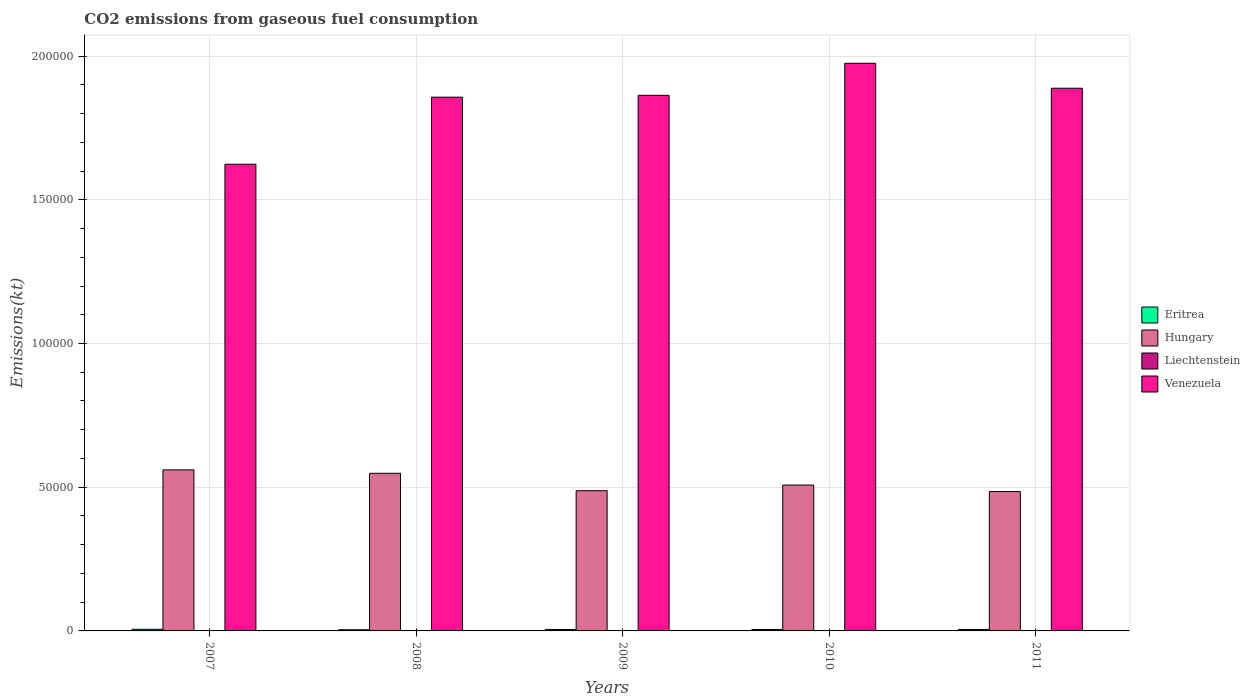How many different coloured bars are there?
Provide a succinct answer. 4. Are the number of bars per tick equal to the number of legend labels?
Ensure brevity in your answer.  Yes. What is the label of the 4th group of bars from the left?
Ensure brevity in your answer.  2010. In how many cases, is the number of bars for a given year not equal to the number of legend labels?
Your response must be concise. 0. What is the amount of CO2 emitted in Eritrea in 2009?
Your answer should be compact. 513.38. Across all years, what is the maximum amount of CO2 emitted in Venezuela?
Ensure brevity in your answer.  1.98e+05. Across all years, what is the minimum amount of CO2 emitted in Hungary?
Keep it short and to the point. 4.85e+04. What is the total amount of CO2 emitted in Liechtenstein in the graph?
Ensure brevity in your answer.  304.36. What is the difference between the amount of CO2 emitted in Eritrea in 2009 and that in 2011?
Offer a terse response. -7.33. What is the difference between the amount of CO2 emitted in Eritrea in 2011 and the amount of CO2 emitted in Hungary in 2010?
Your answer should be very brief. -5.02e+04. What is the average amount of CO2 emitted in Hungary per year?
Give a very brief answer. 5.18e+04. In the year 2011, what is the difference between the amount of CO2 emitted in Eritrea and amount of CO2 emitted in Venezuela?
Your answer should be compact. -1.88e+05. What is the ratio of the amount of CO2 emitted in Venezuela in 2008 to that in 2011?
Make the answer very short. 0.98. Is the amount of CO2 emitted in Hungary in 2007 less than that in 2010?
Offer a very short reply. No. What is the difference between the highest and the second highest amount of CO2 emitted in Venezuela?
Your answer should be very brief. 8694.46. What is the difference between the highest and the lowest amount of CO2 emitted in Venezuela?
Your answer should be compact. 3.51e+04. In how many years, is the amount of CO2 emitted in Liechtenstein greater than the average amount of CO2 emitted in Liechtenstein taken over all years?
Your answer should be very brief. 2. Is the sum of the amount of CO2 emitted in Hungary in 2007 and 2009 greater than the maximum amount of CO2 emitted in Venezuela across all years?
Ensure brevity in your answer.  No. Is it the case that in every year, the sum of the amount of CO2 emitted in Venezuela and amount of CO2 emitted in Liechtenstein is greater than the sum of amount of CO2 emitted in Hungary and amount of CO2 emitted in Eritrea?
Provide a short and direct response. No. What does the 2nd bar from the left in 2008 represents?
Provide a short and direct response. Hungary. What does the 1st bar from the right in 2009 represents?
Provide a short and direct response. Venezuela. How many years are there in the graph?
Offer a very short reply. 5. What is the difference between two consecutive major ticks on the Y-axis?
Offer a terse response. 5.00e+04. Does the graph contain grids?
Ensure brevity in your answer.  Yes. Where does the legend appear in the graph?
Provide a short and direct response. Center right. What is the title of the graph?
Keep it short and to the point. CO2 emissions from gaseous fuel consumption. What is the label or title of the X-axis?
Offer a very short reply. Years. What is the label or title of the Y-axis?
Offer a very short reply. Emissions(kt). What is the Emissions(kt) in Eritrea in 2007?
Keep it short and to the point. 579.39. What is the Emissions(kt) in Hungary in 2007?
Provide a short and direct response. 5.60e+04. What is the Emissions(kt) in Liechtenstein in 2007?
Provide a short and direct response. 69.67. What is the Emissions(kt) in Venezuela in 2007?
Your answer should be very brief. 1.62e+05. What is the Emissions(kt) in Eritrea in 2008?
Offer a terse response. 414.37. What is the Emissions(kt) in Hungary in 2008?
Offer a very short reply. 5.48e+04. What is the Emissions(kt) of Liechtenstein in 2008?
Make the answer very short. 69.67. What is the Emissions(kt) in Venezuela in 2008?
Ensure brevity in your answer.  1.86e+05. What is the Emissions(kt) of Eritrea in 2009?
Provide a short and direct response. 513.38. What is the Emissions(kt) of Hungary in 2009?
Provide a succinct answer. 4.88e+04. What is the Emissions(kt) in Liechtenstein in 2009?
Offer a terse response. 55.01. What is the Emissions(kt) of Venezuela in 2009?
Keep it short and to the point. 1.86e+05. What is the Emissions(kt) of Eritrea in 2010?
Provide a short and direct response. 513.38. What is the Emissions(kt) of Hungary in 2010?
Give a very brief answer. 5.07e+04. What is the Emissions(kt) of Liechtenstein in 2010?
Offer a terse response. 58.67. What is the Emissions(kt) of Venezuela in 2010?
Make the answer very short. 1.98e+05. What is the Emissions(kt) in Eritrea in 2011?
Keep it short and to the point. 520.71. What is the Emissions(kt) in Hungary in 2011?
Provide a succinct answer. 4.85e+04. What is the Emissions(kt) in Liechtenstein in 2011?
Keep it short and to the point. 51.34. What is the Emissions(kt) of Venezuela in 2011?
Provide a short and direct response. 1.89e+05. Across all years, what is the maximum Emissions(kt) in Eritrea?
Your answer should be compact. 579.39. Across all years, what is the maximum Emissions(kt) in Hungary?
Your response must be concise. 5.60e+04. Across all years, what is the maximum Emissions(kt) in Liechtenstein?
Make the answer very short. 69.67. Across all years, what is the maximum Emissions(kt) in Venezuela?
Offer a terse response. 1.98e+05. Across all years, what is the minimum Emissions(kt) of Eritrea?
Provide a succinct answer. 414.37. Across all years, what is the minimum Emissions(kt) of Hungary?
Provide a short and direct response. 4.85e+04. Across all years, what is the minimum Emissions(kt) in Liechtenstein?
Provide a succinct answer. 51.34. Across all years, what is the minimum Emissions(kt) of Venezuela?
Ensure brevity in your answer.  1.62e+05. What is the total Emissions(kt) of Eritrea in the graph?
Offer a very short reply. 2541.23. What is the total Emissions(kt) in Hungary in the graph?
Give a very brief answer. 2.59e+05. What is the total Emissions(kt) in Liechtenstein in the graph?
Your answer should be compact. 304.36. What is the total Emissions(kt) in Venezuela in the graph?
Offer a terse response. 9.21e+05. What is the difference between the Emissions(kt) in Eritrea in 2007 and that in 2008?
Give a very brief answer. 165.01. What is the difference between the Emissions(kt) in Hungary in 2007 and that in 2008?
Offer a very short reply. 1191.78. What is the difference between the Emissions(kt) in Liechtenstein in 2007 and that in 2008?
Provide a succinct answer. 0. What is the difference between the Emissions(kt) in Venezuela in 2007 and that in 2008?
Your answer should be very brief. -2.33e+04. What is the difference between the Emissions(kt) of Eritrea in 2007 and that in 2009?
Ensure brevity in your answer.  66.01. What is the difference between the Emissions(kt) in Hungary in 2007 and that in 2009?
Ensure brevity in your answer.  7253.33. What is the difference between the Emissions(kt) in Liechtenstein in 2007 and that in 2009?
Give a very brief answer. 14.67. What is the difference between the Emissions(kt) in Venezuela in 2007 and that in 2009?
Provide a short and direct response. -2.40e+04. What is the difference between the Emissions(kt) of Eritrea in 2007 and that in 2010?
Make the answer very short. 66.01. What is the difference between the Emissions(kt) in Hungary in 2007 and that in 2010?
Provide a short and direct response. 5287.81. What is the difference between the Emissions(kt) of Liechtenstein in 2007 and that in 2010?
Your answer should be very brief. 11. What is the difference between the Emissions(kt) in Venezuela in 2007 and that in 2010?
Provide a short and direct response. -3.51e+04. What is the difference between the Emissions(kt) in Eritrea in 2007 and that in 2011?
Your answer should be compact. 58.67. What is the difference between the Emissions(kt) in Hungary in 2007 and that in 2011?
Make the answer very short. 7543.02. What is the difference between the Emissions(kt) in Liechtenstein in 2007 and that in 2011?
Your answer should be very brief. 18.34. What is the difference between the Emissions(kt) of Venezuela in 2007 and that in 2011?
Offer a terse response. -2.64e+04. What is the difference between the Emissions(kt) of Eritrea in 2008 and that in 2009?
Offer a very short reply. -99.01. What is the difference between the Emissions(kt) in Hungary in 2008 and that in 2009?
Give a very brief answer. 6061.55. What is the difference between the Emissions(kt) in Liechtenstein in 2008 and that in 2009?
Ensure brevity in your answer.  14.67. What is the difference between the Emissions(kt) in Venezuela in 2008 and that in 2009?
Make the answer very short. -645.39. What is the difference between the Emissions(kt) of Eritrea in 2008 and that in 2010?
Provide a short and direct response. -99.01. What is the difference between the Emissions(kt) in Hungary in 2008 and that in 2010?
Offer a very short reply. 4096.04. What is the difference between the Emissions(kt) in Liechtenstein in 2008 and that in 2010?
Your response must be concise. 11. What is the difference between the Emissions(kt) of Venezuela in 2008 and that in 2010?
Provide a succinct answer. -1.18e+04. What is the difference between the Emissions(kt) in Eritrea in 2008 and that in 2011?
Offer a terse response. -106.34. What is the difference between the Emissions(kt) of Hungary in 2008 and that in 2011?
Your response must be concise. 6351.24. What is the difference between the Emissions(kt) of Liechtenstein in 2008 and that in 2011?
Offer a very short reply. 18.34. What is the difference between the Emissions(kt) of Venezuela in 2008 and that in 2011?
Provide a short and direct response. -3109.62. What is the difference between the Emissions(kt) in Hungary in 2009 and that in 2010?
Ensure brevity in your answer.  -1965.51. What is the difference between the Emissions(kt) of Liechtenstein in 2009 and that in 2010?
Offer a terse response. -3.67. What is the difference between the Emissions(kt) in Venezuela in 2009 and that in 2010?
Offer a terse response. -1.12e+04. What is the difference between the Emissions(kt) of Eritrea in 2009 and that in 2011?
Provide a succinct answer. -7.33. What is the difference between the Emissions(kt) in Hungary in 2009 and that in 2011?
Your response must be concise. 289.69. What is the difference between the Emissions(kt) in Liechtenstein in 2009 and that in 2011?
Provide a succinct answer. 3.67. What is the difference between the Emissions(kt) of Venezuela in 2009 and that in 2011?
Ensure brevity in your answer.  -2464.22. What is the difference between the Emissions(kt) of Eritrea in 2010 and that in 2011?
Offer a very short reply. -7.33. What is the difference between the Emissions(kt) in Hungary in 2010 and that in 2011?
Your answer should be compact. 2255.2. What is the difference between the Emissions(kt) in Liechtenstein in 2010 and that in 2011?
Your answer should be very brief. 7.33. What is the difference between the Emissions(kt) of Venezuela in 2010 and that in 2011?
Keep it short and to the point. 8694.46. What is the difference between the Emissions(kt) in Eritrea in 2007 and the Emissions(kt) in Hungary in 2008?
Provide a succinct answer. -5.43e+04. What is the difference between the Emissions(kt) of Eritrea in 2007 and the Emissions(kt) of Liechtenstein in 2008?
Provide a short and direct response. 509.71. What is the difference between the Emissions(kt) in Eritrea in 2007 and the Emissions(kt) in Venezuela in 2008?
Keep it short and to the point. -1.85e+05. What is the difference between the Emissions(kt) in Hungary in 2007 and the Emissions(kt) in Liechtenstein in 2008?
Ensure brevity in your answer.  5.60e+04. What is the difference between the Emissions(kt) in Hungary in 2007 and the Emissions(kt) in Venezuela in 2008?
Offer a very short reply. -1.30e+05. What is the difference between the Emissions(kt) of Liechtenstein in 2007 and the Emissions(kt) of Venezuela in 2008?
Give a very brief answer. -1.86e+05. What is the difference between the Emissions(kt) in Eritrea in 2007 and the Emissions(kt) in Hungary in 2009?
Give a very brief answer. -4.82e+04. What is the difference between the Emissions(kt) of Eritrea in 2007 and the Emissions(kt) of Liechtenstein in 2009?
Keep it short and to the point. 524.38. What is the difference between the Emissions(kt) of Eritrea in 2007 and the Emissions(kt) of Venezuela in 2009?
Provide a short and direct response. -1.86e+05. What is the difference between the Emissions(kt) in Hungary in 2007 and the Emissions(kt) in Liechtenstein in 2009?
Give a very brief answer. 5.60e+04. What is the difference between the Emissions(kt) of Hungary in 2007 and the Emissions(kt) of Venezuela in 2009?
Provide a succinct answer. -1.30e+05. What is the difference between the Emissions(kt) of Liechtenstein in 2007 and the Emissions(kt) of Venezuela in 2009?
Keep it short and to the point. -1.86e+05. What is the difference between the Emissions(kt) of Eritrea in 2007 and the Emissions(kt) of Hungary in 2010?
Your answer should be compact. -5.02e+04. What is the difference between the Emissions(kt) of Eritrea in 2007 and the Emissions(kt) of Liechtenstein in 2010?
Offer a terse response. 520.71. What is the difference between the Emissions(kt) of Eritrea in 2007 and the Emissions(kt) of Venezuela in 2010?
Give a very brief answer. -1.97e+05. What is the difference between the Emissions(kt) of Hungary in 2007 and the Emissions(kt) of Liechtenstein in 2010?
Offer a very short reply. 5.60e+04. What is the difference between the Emissions(kt) of Hungary in 2007 and the Emissions(kt) of Venezuela in 2010?
Ensure brevity in your answer.  -1.41e+05. What is the difference between the Emissions(kt) in Liechtenstein in 2007 and the Emissions(kt) in Venezuela in 2010?
Provide a short and direct response. -1.97e+05. What is the difference between the Emissions(kt) of Eritrea in 2007 and the Emissions(kt) of Hungary in 2011?
Keep it short and to the point. -4.79e+04. What is the difference between the Emissions(kt) of Eritrea in 2007 and the Emissions(kt) of Liechtenstein in 2011?
Keep it short and to the point. 528.05. What is the difference between the Emissions(kt) in Eritrea in 2007 and the Emissions(kt) in Venezuela in 2011?
Offer a terse response. -1.88e+05. What is the difference between the Emissions(kt) of Hungary in 2007 and the Emissions(kt) of Liechtenstein in 2011?
Make the answer very short. 5.60e+04. What is the difference between the Emissions(kt) of Hungary in 2007 and the Emissions(kt) of Venezuela in 2011?
Keep it short and to the point. -1.33e+05. What is the difference between the Emissions(kt) of Liechtenstein in 2007 and the Emissions(kt) of Venezuela in 2011?
Ensure brevity in your answer.  -1.89e+05. What is the difference between the Emissions(kt) in Eritrea in 2008 and the Emissions(kt) in Hungary in 2009?
Keep it short and to the point. -4.84e+04. What is the difference between the Emissions(kt) of Eritrea in 2008 and the Emissions(kt) of Liechtenstein in 2009?
Make the answer very short. 359.37. What is the difference between the Emissions(kt) of Eritrea in 2008 and the Emissions(kt) of Venezuela in 2009?
Your answer should be very brief. -1.86e+05. What is the difference between the Emissions(kt) in Hungary in 2008 and the Emissions(kt) in Liechtenstein in 2009?
Make the answer very short. 5.48e+04. What is the difference between the Emissions(kt) in Hungary in 2008 and the Emissions(kt) in Venezuela in 2009?
Keep it short and to the point. -1.32e+05. What is the difference between the Emissions(kt) of Liechtenstein in 2008 and the Emissions(kt) of Venezuela in 2009?
Ensure brevity in your answer.  -1.86e+05. What is the difference between the Emissions(kt) of Eritrea in 2008 and the Emissions(kt) of Hungary in 2010?
Ensure brevity in your answer.  -5.03e+04. What is the difference between the Emissions(kt) of Eritrea in 2008 and the Emissions(kt) of Liechtenstein in 2010?
Offer a very short reply. 355.7. What is the difference between the Emissions(kt) in Eritrea in 2008 and the Emissions(kt) in Venezuela in 2010?
Keep it short and to the point. -1.97e+05. What is the difference between the Emissions(kt) in Hungary in 2008 and the Emissions(kt) in Liechtenstein in 2010?
Offer a terse response. 5.48e+04. What is the difference between the Emissions(kt) in Hungary in 2008 and the Emissions(kt) in Venezuela in 2010?
Ensure brevity in your answer.  -1.43e+05. What is the difference between the Emissions(kt) of Liechtenstein in 2008 and the Emissions(kt) of Venezuela in 2010?
Provide a succinct answer. -1.97e+05. What is the difference between the Emissions(kt) in Eritrea in 2008 and the Emissions(kt) in Hungary in 2011?
Keep it short and to the point. -4.81e+04. What is the difference between the Emissions(kt) in Eritrea in 2008 and the Emissions(kt) in Liechtenstein in 2011?
Make the answer very short. 363.03. What is the difference between the Emissions(kt) in Eritrea in 2008 and the Emissions(kt) in Venezuela in 2011?
Your response must be concise. -1.88e+05. What is the difference between the Emissions(kt) in Hungary in 2008 and the Emissions(kt) in Liechtenstein in 2011?
Your response must be concise. 5.48e+04. What is the difference between the Emissions(kt) of Hungary in 2008 and the Emissions(kt) of Venezuela in 2011?
Make the answer very short. -1.34e+05. What is the difference between the Emissions(kt) in Liechtenstein in 2008 and the Emissions(kt) in Venezuela in 2011?
Provide a short and direct response. -1.89e+05. What is the difference between the Emissions(kt) in Eritrea in 2009 and the Emissions(kt) in Hungary in 2010?
Make the answer very short. -5.02e+04. What is the difference between the Emissions(kt) of Eritrea in 2009 and the Emissions(kt) of Liechtenstein in 2010?
Provide a short and direct response. 454.71. What is the difference between the Emissions(kt) in Eritrea in 2009 and the Emissions(kt) in Venezuela in 2010?
Ensure brevity in your answer.  -1.97e+05. What is the difference between the Emissions(kt) of Hungary in 2009 and the Emissions(kt) of Liechtenstein in 2010?
Keep it short and to the point. 4.87e+04. What is the difference between the Emissions(kt) in Hungary in 2009 and the Emissions(kt) in Venezuela in 2010?
Give a very brief answer. -1.49e+05. What is the difference between the Emissions(kt) of Liechtenstein in 2009 and the Emissions(kt) of Venezuela in 2010?
Make the answer very short. -1.97e+05. What is the difference between the Emissions(kt) of Eritrea in 2009 and the Emissions(kt) of Hungary in 2011?
Provide a succinct answer. -4.80e+04. What is the difference between the Emissions(kt) in Eritrea in 2009 and the Emissions(kt) in Liechtenstein in 2011?
Offer a very short reply. 462.04. What is the difference between the Emissions(kt) of Eritrea in 2009 and the Emissions(kt) of Venezuela in 2011?
Your response must be concise. -1.88e+05. What is the difference between the Emissions(kt) of Hungary in 2009 and the Emissions(kt) of Liechtenstein in 2011?
Your response must be concise. 4.87e+04. What is the difference between the Emissions(kt) in Hungary in 2009 and the Emissions(kt) in Venezuela in 2011?
Provide a succinct answer. -1.40e+05. What is the difference between the Emissions(kt) of Liechtenstein in 2009 and the Emissions(kt) of Venezuela in 2011?
Provide a succinct answer. -1.89e+05. What is the difference between the Emissions(kt) of Eritrea in 2010 and the Emissions(kt) of Hungary in 2011?
Provide a succinct answer. -4.80e+04. What is the difference between the Emissions(kt) of Eritrea in 2010 and the Emissions(kt) of Liechtenstein in 2011?
Your answer should be very brief. 462.04. What is the difference between the Emissions(kt) in Eritrea in 2010 and the Emissions(kt) in Venezuela in 2011?
Offer a terse response. -1.88e+05. What is the difference between the Emissions(kt) in Hungary in 2010 and the Emissions(kt) in Liechtenstein in 2011?
Give a very brief answer. 5.07e+04. What is the difference between the Emissions(kt) of Hungary in 2010 and the Emissions(kt) of Venezuela in 2011?
Your response must be concise. -1.38e+05. What is the difference between the Emissions(kt) of Liechtenstein in 2010 and the Emissions(kt) of Venezuela in 2011?
Offer a terse response. -1.89e+05. What is the average Emissions(kt) in Eritrea per year?
Your response must be concise. 508.25. What is the average Emissions(kt) of Hungary per year?
Provide a short and direct response. 5.18e+04. What is the average Emissions(kt) in Liechtenstein per year?
Make the answer very short. 60.87. What is the average Emissions(kt) in Venezuela per year?
Make the answer very short. 1.84e+05. In the year 2007, what is the difference between the Emissions(kt) of Eritrea and Emissions(kt) of Hungary?
Provide a succinct answer. -5.55e+04. In the year 2007, what is the difference between the Emissions(kt) of Eritrea and Emissions(kt) of Liechtenstein?
Keep it short and to the point. 509.71. In the year 2007, what is the difference between the Emissions(kt) of Eritrea and Emissions(kt) of Venezuela?
Provide a short and direct response. -1.62e+05. In the year 2007, what is the difference between the Emissions(kt) of Hungary and Emissions(kt) of Liechtenstein?
Give a very brief answer. 5.60e+04. In the year 2007, what is the difference between the Emissions(kt) of Hungary and Emissions(kt) of Venezuela?
Your answer should be compact. -1.06e+05. In the year 2007, what is the difference between the Emissions(kt) in Liechtenstein and Emissions(kt) in Venezuela?
Your response must be concise. -1.62e+05. In the year 2008, what is the difference between the Emissions(kt) in Eritrea and Emissions(kt) in Hungary?
Make the answer very short. -5.44e+04. In the year 2008, what is the difference between the Emissions(kt) in Eritrea and Emissions(kt) in Liechtenstein?
Your answer should be compact. 344.7. In the year 2008, what is the difference between the Emissions(kt) in Eritrea and Emissions(kt) in Venezuela?
Give a very brief answer. -1.85e+05. In the year 2008, what is the difference between the Emissions(kt) in Hungary and Emissions(kt) in Liechtenstein?
Ensure brevity in your answer.  5.48e+04. In the year 2008, what is the difference between the Emissions(kt) of Hungary and Emissions(kt) of Venezuela?
Provide a short and direct response. -1.31e+05. In the year 2008, what is the difference between the Emissions(kt) of Liechtenstein and Emissions(kt) of Venezuela?
Your answer should be compact. -1.86e+05. In the year 2009, what is the difference between the Emissions(kt) of Eritrea and Emissions(kt) of Hungary?
Your answer should be very brief. -4.83e+04. In the year 2009, what is the difference between the Emissions(kt) in Eritrea and Emissions(kt) in Liechtenstein?
Offer a very short reply. 458.38. In the year 2009, what is the difference between the Emissions(kt) in Eritrea and Emissions(kt) in Venezuela?
Offer a very short reply. -1.86e+05. In the year 2009, what is the difference between the Emissions(kt) in Hungary and Emissions(kt) in Liechtenstein?
Provide a succinct answer. 4.87e+04. In the year 2009, what is the difference between the Emissions(kt) in Hungary and Emissions(kt) in Venezuela?
Offer a very short reply. -1.38e+05. In the year 2009, what is the difference between the Emissions(kt) of Liechtenstein and Emissions(kt) of Venezuela?
Your response must be concise. -1.86e+05. In the year 2010, what is the difference between the Emissions(kt) in Eritrea and Emissions(kt) in Hungary?
Offer a very short reply. -5.02e+04. In the year 2010, what is the difference between the Emissions(kt) in Eritrea and Emissions(kt) in Liechtenstein?
Provide a short and direct response. 454.71. In the year 2010, what is the difference between the Emissions(kt) of Eritrea and Emissions(kt) of Venezuela?
Offer a very short reply. -1.97e+05. In the year 2010, what is the difference between the Emissions(kt) of Hungary and Emissions(kt) of Liechtenstein?
Give a very brief answer. 5.07e+04. In the year 2010, what is the difference between the Emissions(kt) of Hungary and Emissions(kt) of Venezuela?
Your answer should be compact. -1.47e+05. In the year 2010, what is the difference between the Emissions(kt) in Liechtenstein and Emissions(kt) in Venezuela?
Give a very brief answer. -1.97e+05. In the year 2011, what is the difference between the Emissions(kt) of Eritrea and Emissions(kt) of Hungary?
Your answer should be compact. -4.80e+04. In the year 2011, what is the difference between the Emissions(kt) of Eritrea and Emissions(kt) of Liechtenstein?
Offer a terse response. 469.38. In the year 2011, what is the difference between the Emissions(kt) in Eritrea and Emissions(kt) in Venezuela?
Keep it short and to the point. -1.88e+05. In the year 2011, what is the difference between the Emissions(kt) in Hungary and Emissions(kt) in Liechtenstein?
Make the answer very short. 4.84e+04. In the year 2011, what is the difference between the Emissions(kt) in Hungary and Emissions(kt) in Venezuela?
Your answer should be very brief. -1.40e+05. In the year 2011, what is the difference between the Emissions(kt) in Liechtenstein and Emissions(kt) in Venezuela?
Your response must be concise. -1.89e+05. What is the ratio of the Emissions(kt) of Eritrea in 2007 to that in 2008?
Offer a terse response. 1.4. What is the ratio of the Emissions(kt) in Hungary in 2007 to that in 2008?
Offer a terse response. 1.02. What is the ratio of the Emissions(kt) in Liechtenstein in 2007 to that in 2008?
Keep it short and to the point. 1. What is the ratio of the Emissions(kt) in Venezuela in 2007 to that in 2008?
Offer a very short reply. 0.87. What is the ratio of the Emissions(kt) of Eritrea in 2007 to that in 2009?
Offer a terse response. 1.13. What is the ratio of the Emissions(kt) in Hungary in 2007 to that in 2009?
Make the answer very short. 1.15. What is the ratio of the Emissions(kt) of Liechtenstein in 2007 to that in 2009?
Offer a terse response. 1.27. What is the ratio of the Emissions(kt) in Venezuela in 2007 to that in 2009?
Your answer should be very brief. 0.87. What is the ratio of the Emissions(kt) of Eritrea in 2007 to that in 2010?
Provide a succinct answer. 1.13. What is the ratio of the Emissions(kt) in Hungary in 2007 to that in 2010?
Offer a very short reply. 1.1. What is the ratio of the Emissions(kt) of Liechtenstein in 2007 to that in 2010?
Offer a terse response. 1.19. What is the ratio of the Emissions(kt) in Venezuela in 2007 to that in 2010?
Make the answer very short. 0.82. What is the ratio of the Emissions(kt) of Eritrea in 2007 to that in 2011?
Ensure brevity in your answer.  1.11. What is the ratio of the Emissions(kt) in Hungary in 2007 to that in 2011?
Provide a short and direct response. 1.16. What is the ratio of the Emissions(kt) of Liechtenstein in 2007 to that in 2011?
Offer a terse response. 1.36. What is the ratio of the Emissions(kt) in Venezuela in 2007 to that in 2011?
Your answer should be very brief. 0.86. What is the ratio of the Emissions(kt) in Eritrea in 2008 to that in 2009?
Ensure brevity in your answer.  0.81. What is the ratio of the Emissions(kt) of Hungary in 2008 to that in 2009?
Your answer should be compact. 1.12. What is the ratio of the Emissions(kt) in Liechtenstein in 2008 to that in 2009?
Give a very brief answer. 1.27. What is the ratio of the Emissions(kt) of Venezuela in 2008 to that in 2009?
Provide a succinct answer. 1. What is the ratio of the Emissions(kt) in Eritrea in 2008 to that in 2010?
Your answer should be very brief. 0.81. What is the ratio of the Emissions(kt) of Hungary in 2008 to that in 2010?
Your response must be concise. 1.08. What is the ratio of the Emissions(kt) of Liechtenstein in 2008 to that in 2010?
Keep it short and to the point. 1.19. What is the ratio of the Emissions(kt) of Venezuela in 2008 to that in 2010?
Keep it short and to the point. 0.94. What is the ratio of the Emissions(kt) of Eritrea in 2008 to that in 2011?
Ensure brevity in your answer.  0.8. What is the ratio of the Emissions(kt) in Hungary in 2008 to that in 2011?
Offer a very short reply. 1.13. What is the ratio of the Emissions(kt) in Liechtenstein in 2008 to that in 2011?
Ensure brevity in your answer.  1.36. What is the ratio of the Emissions(kt) of Venezuela in 2008 to that in 2011?
Make the answer very short. 0.98. What is the ratio of the Emissions(kt) in Eritrea in 2009 to that in 2010?
Offer a terse response. 1. What is the ratio of the Emissions(kt) of Hungary in 2009 to that in 2010?
Your answer should be very brief. 0.96. What is the ratio of the Emissions(kt) of Venezuela in 2009 to that in 2010?
Offer a terse response. 0.94. What is the ratio of the Emissions(kt) of Eritrea in 2009 to that in 2011?
Offer a very short reply. 0.99. What is the ratio of the Emissions(kt) of Liechtenstein in 2009 to that in 2011?
Provide a short and direct response. 1.07. What is the ratio of the Emissions(kt) of Venezuela in 2009 to that in 2011?
Provide a short and direct response. 0.99. What is the ratio of the Emissions(kt) of Eritrea in 2010 to that in 2011?
Keep it short and to the point. 0.99. What is the ratio of the Emissions(kt) in Hungary in 2010 to that in 2011?
Ensure brevity in your answer.  1.05. What is the ratio of the Emissions(kt) in Venezuela in 2010 to that in 2011?
Ensure brevity in your answer.  1.05. What is the difference between the highest and the second highest Emissions(kt) in Eritrea?
Your answer should be very brief. 58.67. What is the difference between the highest and the second highest Emissions(kt) of Hungary?
Provide a short and direct response. 1191.78. What is the difference between the highest and the second highest Emissions(kt) in Venezuela?
Keep it short and to the point. 8694.46. What is the difference between the highest and the lowest Emissions(kt) of Eritrea?
Offer a terse response. 165.01. What is the difference between the highest and the lowest Emissions(kt) of Hungary?
Offer a terse response. 7543.02. What is the difference between the highest and the lowest Emissions(kt) in Liechtenstein?
Provide a succinct answer. 18.34. What is the difference between the highest and the lowest Emissions(kt) in Venezuela?
Make the answer very short. 3.51e+04. 